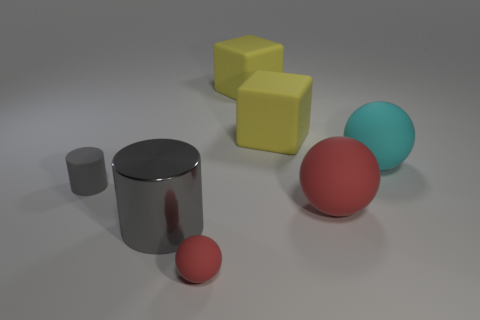Subtract all big rubber balls. How many balls are left? 1 Subtract all cyan balls. How many balls are left? 2 Subtract 2 spheres. How many spheres are left? 1 Add 3 red spheres. How many objects exist? 10 Subtract all big green shiny objects. Subtract all tiny gray cylinders. How many objects are left? 6 Add 7 balls. How many balls are left? 10 Add 2 tiny purple blocks. How many tiny purple blocks exist? 2 Subtract 0 brown balls. How many objects are left? 7 Subtract all blocks. How many objects are left? 5 Subtract all purple cylinders. Subtract all brown balls. How many cylinders are left? 2 